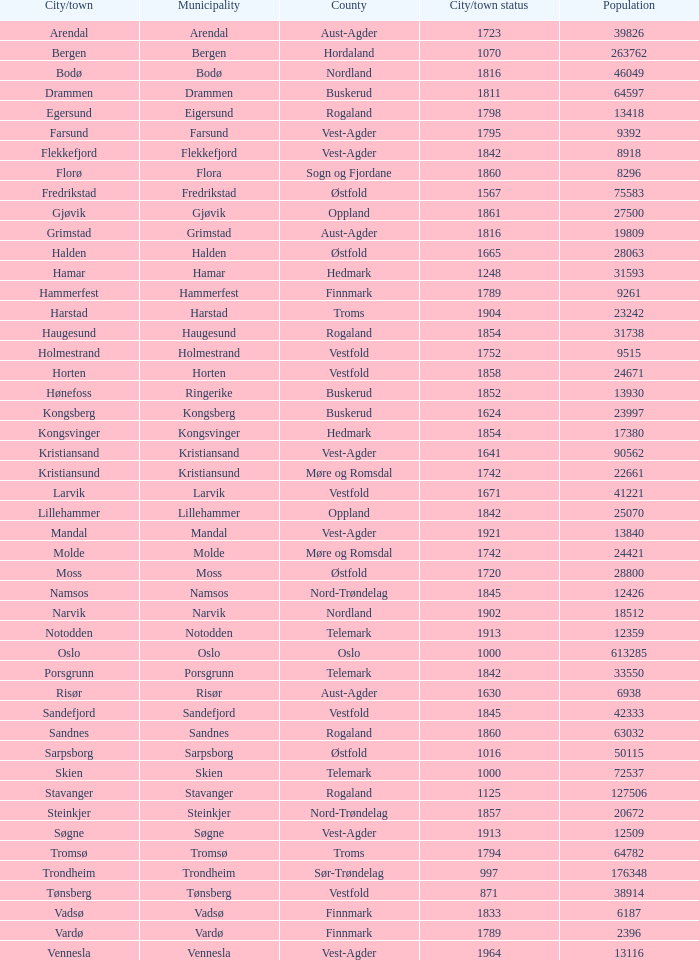What are the cities/towns located in the municipality of Horten? Horten. 